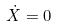<formula> <loc_0><loc_0><loc_500><loc_500>\dot { X } = 0</formula> 